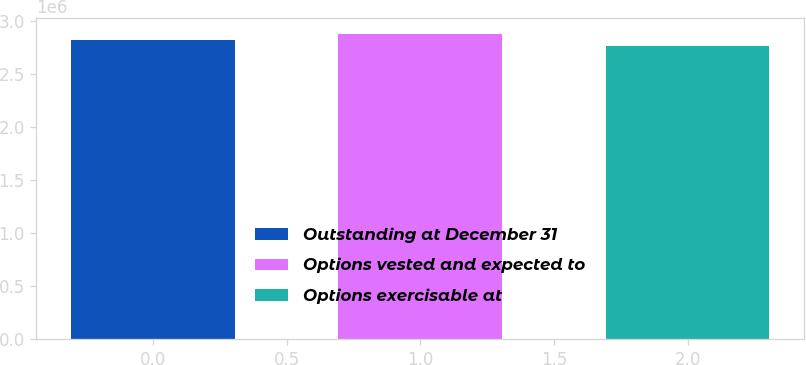Convert chart. <chart><loc_0><loc_0><loc_500><loc_500><bar_chart><fcel>Outstanding at December 31<fcel>Options vested and expected to<fcel>Options exercisable at<nl><fcel>2.8239e+06<fcel>2.8812e+06<fcel>2.76273e+06<nl></chart> 